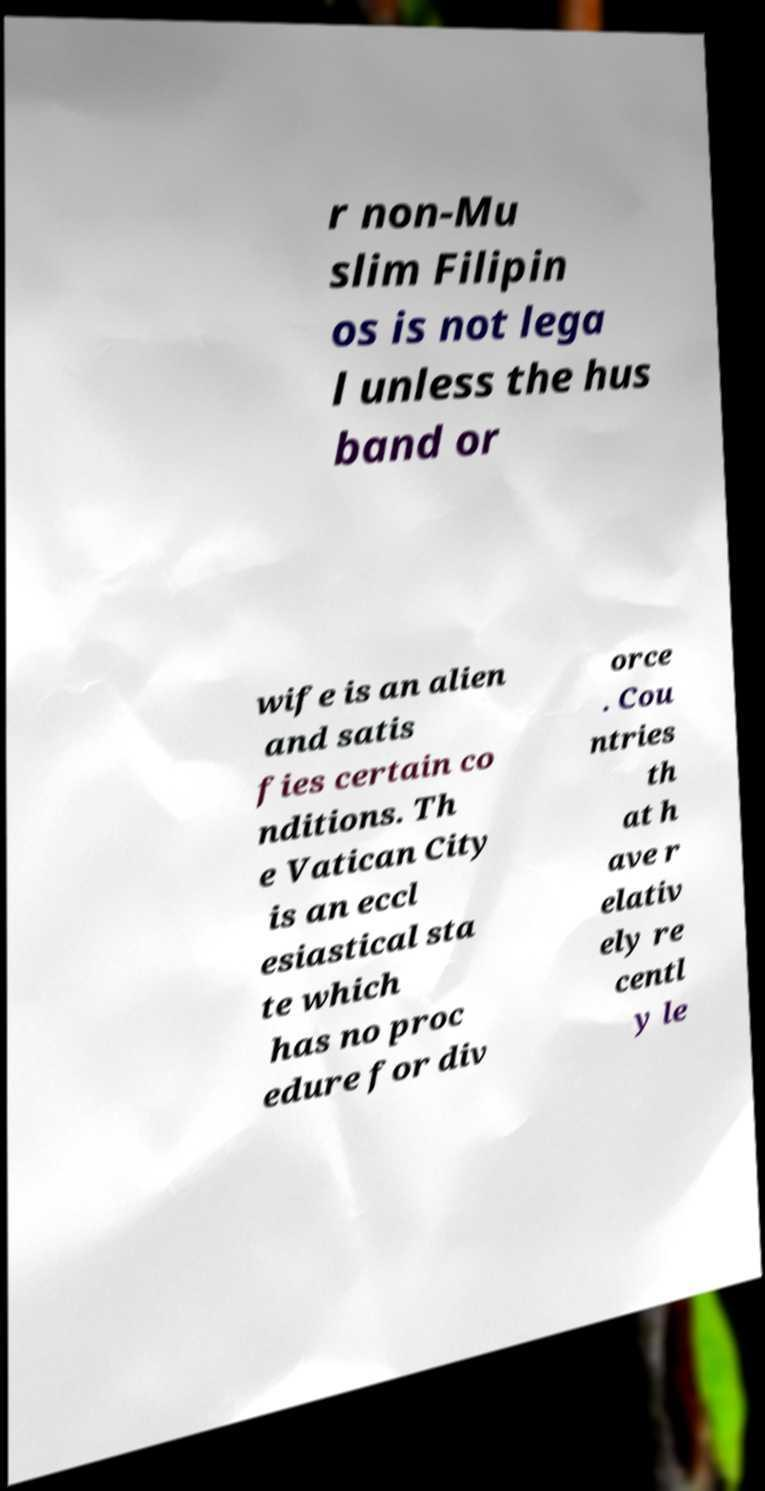For documentation purposes, I need the text within this image transcribed. Could you provide that? r non-Mu slim Filipin os is not lega l unless the hus band or wife is an alien and satis fies certain co nditions. Th e Vatican City is an eccl esiastical sta te which has no proc edure for div orce . Cou ntries th at h ave r elativ ely re centl y le 